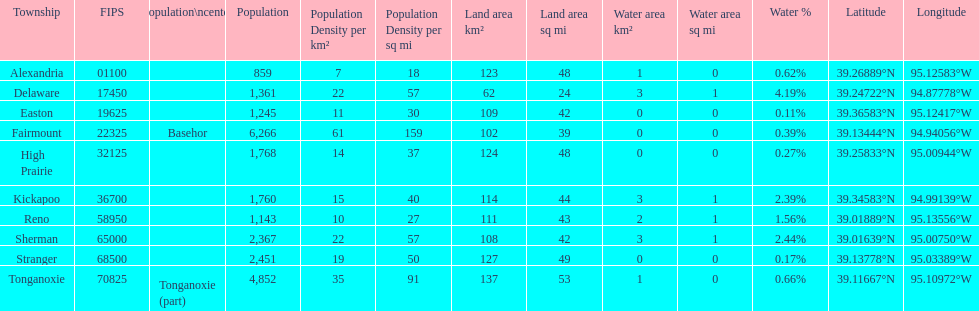What is the difference of population in easton and reno? 102. 